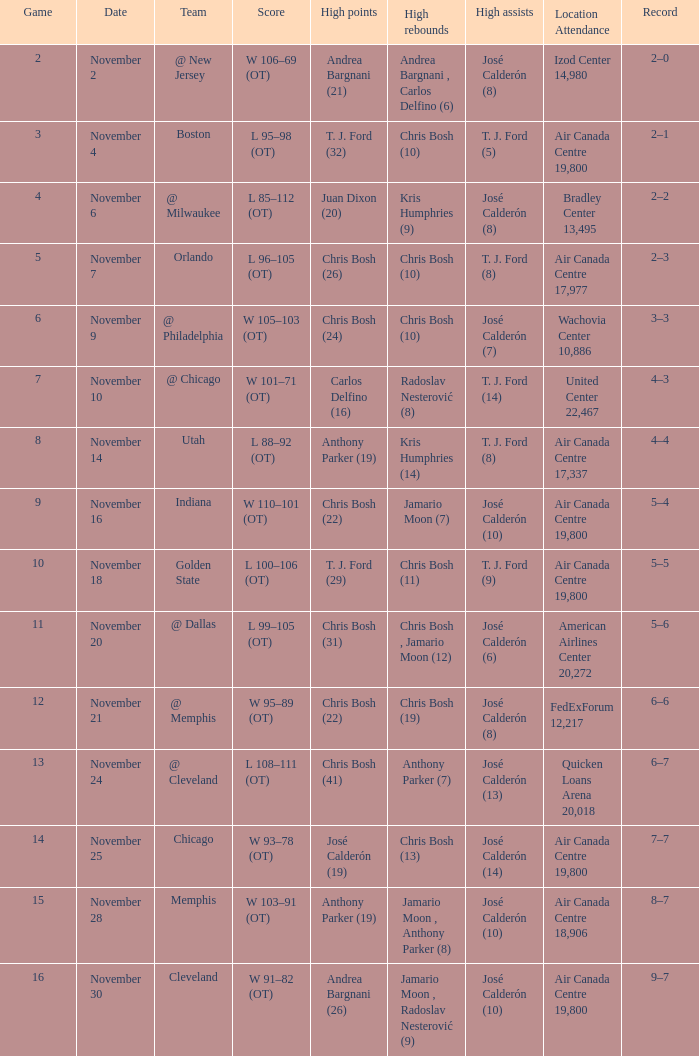Who had the high points when chris bosh (13) had the high rebounds? José Calderón (19). 